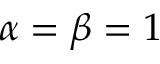Convert formula to latex. <formula><loc_0><loc_0><loc_500><loc_500>\alpha = \beta = 1</formula> 